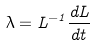<formula> <loc_0><loc_0><loc_500><loc_500>\lambda = L ^ { - 1 } \frac { d L } { d t }</formula> 